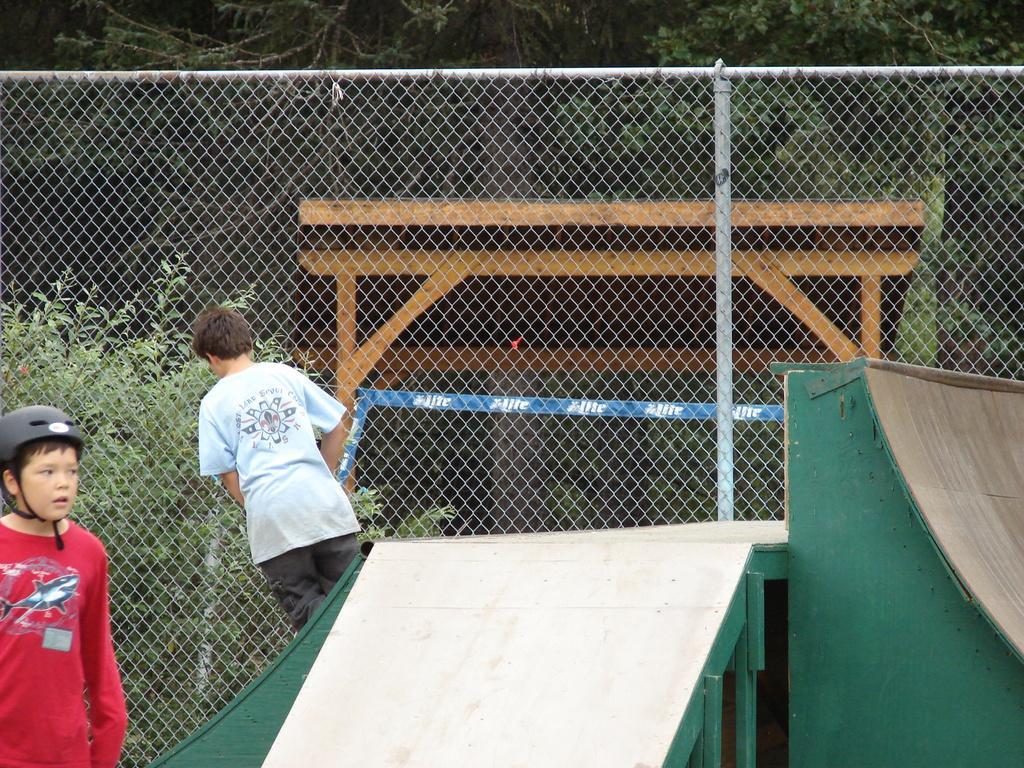In one or two sentences, can you explain what this image depicts? This is a picture taken in skate park. On the left there are two kids. In the center there is a fencing, outside the fencing there are trees and wooden frames. 